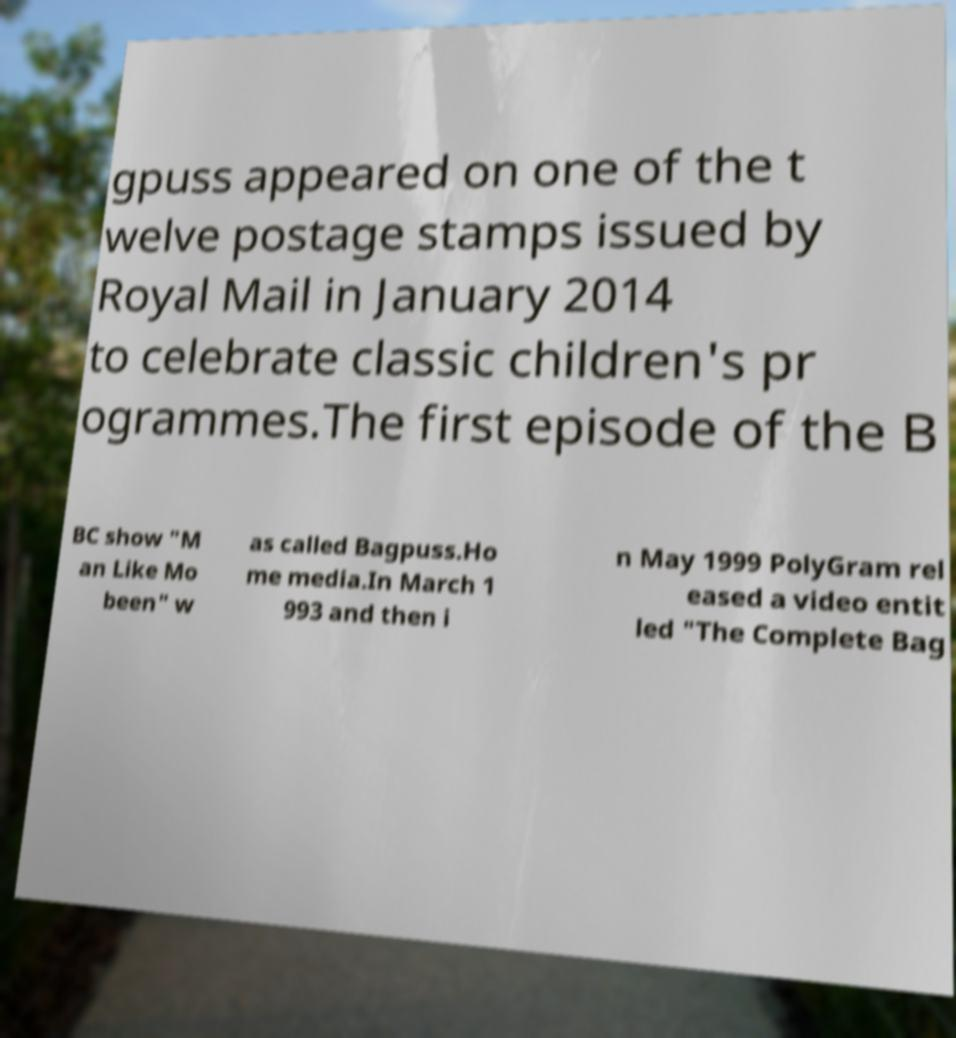Please identify and transcribe the text found in this image. gpuss appeared on one of the t welve postage stamps issued by Royal Mail in January 2014 to celebrate classic children's pr ogrammes.The first episode of the B BC show "M an Like Mo been" w as called Bagpuss.Ho me media.In March 1 993 and then i n May 1999 PolyGram rel eased a video entit led "The Complete Bag 